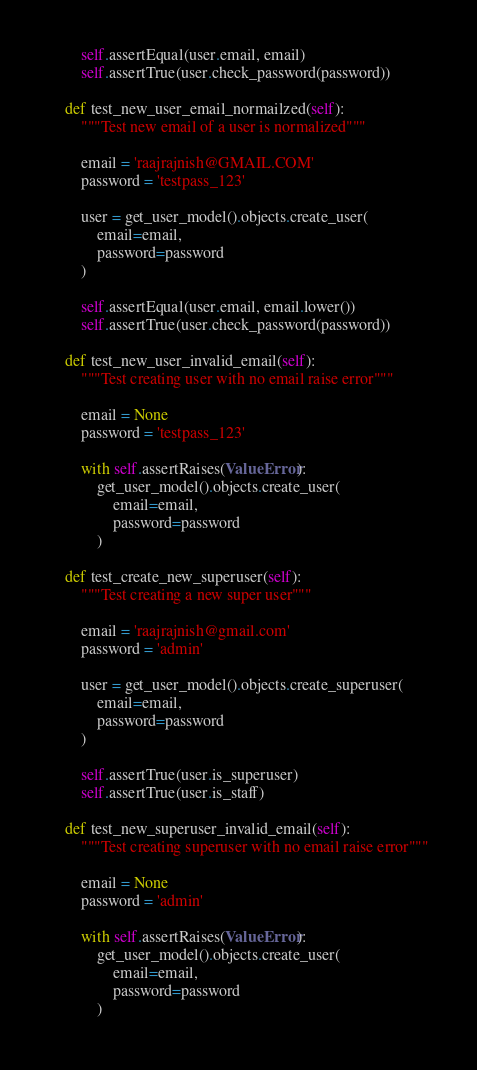<code> <loc_0><loc_0><loc_500><loc_500><_Python_>
        self.assertEqual(user.email, email)
        self.assertTrue(user.check_password(password))

    def test_new_user_email_normailzed(self):
        """Test new email of a user is normalized"""

        email = 'raajrajnish@GMAIL.COM'
        password = 'testpass_123'

        user = get_user_model().objects.create_user(
            email=email,
            password=password
        )

        self.assertEqual(user.email, email.lower())
        self.assertTrue(user.check_password(password))

    def test_new_user_invalid_email(self):
        """Test creating user with no email raise error"""

        email = None
        password = 'testpass_123'

        with self.assertRaises(ValueError):
            get_user_model().objects.create_user(
                email=email,
                password=password
            )

    def test_create_new_superuser(self):
        """Test creating a new super user"""

        email = 'raajrajnish@gmail.com'
        password = 'admin'

        user = get_user_model().objects.create_superuser(
            email=email,
            password=password
        )

        self.assertTrue(user.is_superuser)
        self.assertTrue(user.is_staff)

    def test_new_superuser_invalid_email(self):
        """Test creating superuser with no email raise error"""

        email = None
        password = 'admin'

        with self.assertRaises(ValueError):
            get_user_model().objects.create_user(
                email=email,
                password=password
            )
</code> 